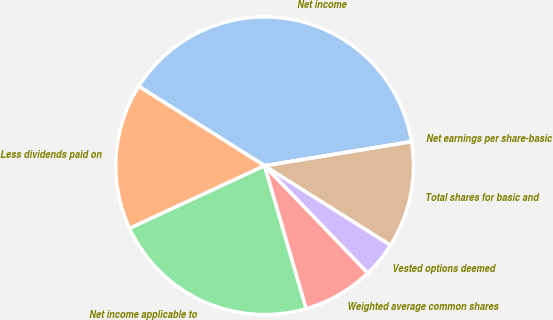Convert chart to OTSL. <chart><loc_0><loc_0><loc_500><loc_500><pie_chart><fcel>Net income<fcel>Less dividends paid on<fcel>Net income applicable to<fcel>Weighted average common shares<fcel>Vested options deemed<fcel>Total shares for basic and<fcel>Net earnings per share-basic<nl><fcel>38.46%<fcel>15.87%<fcel>22.59%<fcel>7.69%<fcel>3.85%<fcel>11.54%<fcel>0.0%<nl></chart> 